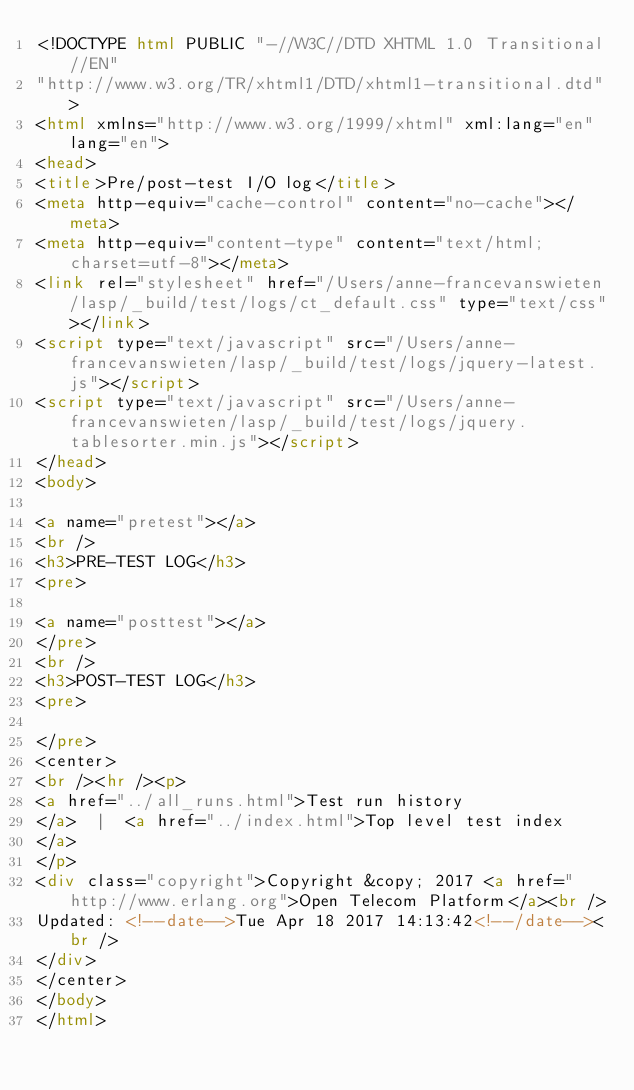Convert code to text. <code><loc_0><loc_0><loc_500><loc_500><_HTML_><!DOCTYPE html PUBLIC "-//W3C//DTD XHTML 1.0 Transitional//EN"
"http://www.w3.org/TR/xhtml1/DTD/xhtml1-transitional.dtd">
<html xmlns="http://www.w3.org/1999/xhtml" xml:lang="en" lang="en">
<head>
<title>Pre/post-test I/O log</title>
<meta http-equiv="cache-control" content="no-cache"></meta>
<meta http-equiv="content-type" content="text/html; charset=utf-8"></meta>
<link rel="stylesheet" href="/Users/anne-francevanswieten/lasp/_build/test/logs/ct_default.css" type="text/css"></link>
<script type="text/javascript" src="/Users/anne-francevanswieten/lasp/_build/test/logs/jquery-latest.js"></script>
<script type="text/javascript" src="/Users/anne-francevanswieten/lasp/_build/test/logs/jquery.tablesorter.min.js"></script>
</head>
<body>

<a name="pretest"></a>
<br />
<h3>PRE-TEST LOG</h3>
<pre>

<a name="posttest"></a>
</pre>
<br />
<h3>POST-TEST LOG</h3>
<pre>

</pre>
<center>
<br /><hr /><p>
<a href="../all_runs.html">Test run history
</a>  |  <a href="../index.html">Top level test index
</a>
</p>
<div class="copyright">Copyright &copy; 2017 <a href="http://www.erlang.org">Open Telecom Platform</a><br />
Updated: <!--date-->Tue Apr 18 2017 14:13:42<!--/date--><br />
</div>
</center>
</body>
</html>
</code> 